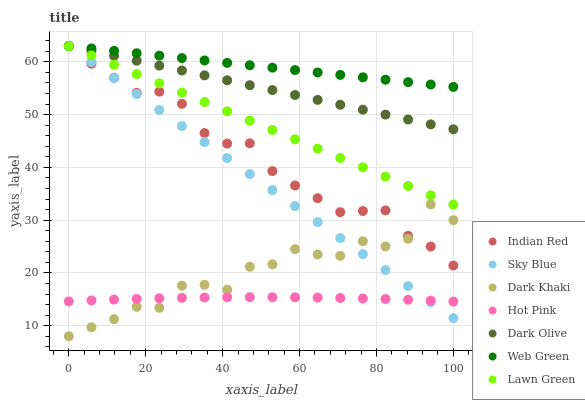Does Hot Pink have the minimum area under the curve?
Answer yes or no. Yes. Does Web Green have the maximum area under the curve?
Answer yes or no. Yes. Does Dark Olive have the minimum area under the curve?
Answer yes or no. No. Does Dark Olive have the maximum area under the curve?
Answer yes or no. No. Is Dark Olive the smoothest?
Answer yes or no. Yes. Is Dark Khaki the roughest?
Answer yes or no. Yes. Is Hot Pink the smoothest?
Answer yes or no. No. Is Hot Pink the roughest?
Answer yes or no. No. Does Dark Khaki have the lowest value?
Answer yes or no. Yes. Does Dark Olive have the lowest value?
Answer yes or no. No. Does Sky Blue have the highest value?
Answer yes or no. Yes. Does Hot Pink have the highest value?
Answer yes or no. No. Is Dark Khaki less than Lawn Green?
Answer yes or no. Yes. Is Web Green greater than Hot Pink?
Answer yes or no. Yes. Does Lawn Green intersect Web Green?
Answer yes or no. Yes. Is Lawn Green less than Web Green?
Answer yes or no. No. Is Lawn Green greater than Web Green?
Answer yes or no. No. Does Dark Khaki intersect Lawn Green?
Answer yes or no. No. 